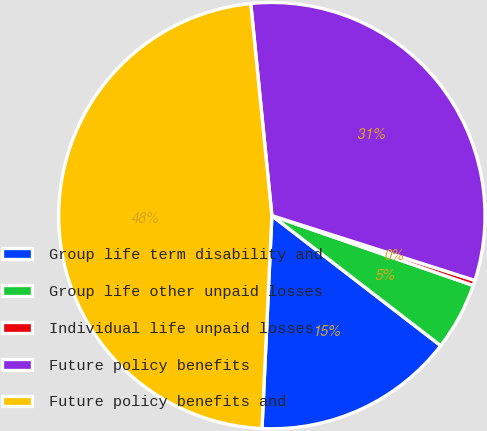Convert chart to OTSL. <chart><loc_0><loc_0><loc_500><loc_500><pie_chart><fcel>Group life term disability and<fcel>Group life other unpaid losses<fcel>Individual life unpaid losses<fcel>Future policy benefits<fcel>Future policy benefits and<nl><fcel>15.29%<fcel>5.13%<fcel>0.4%<fcel>31.49%<fcel>47.68%<nl></chart> 